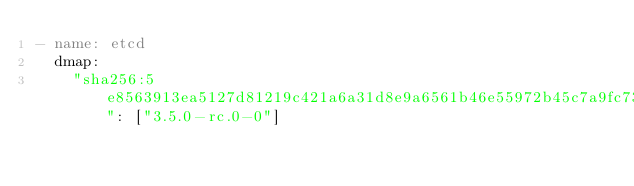<code> <loc_0><loc_0><loc_500><loc_500><_YAML_>- name: etcd
  dmap:
    "sha256:5e8563913ea5127d81219c421a6a31d8e9a6561b46e55972b45c7a9fc739500e": ["3.5.0-rc.0-0"]</code> 